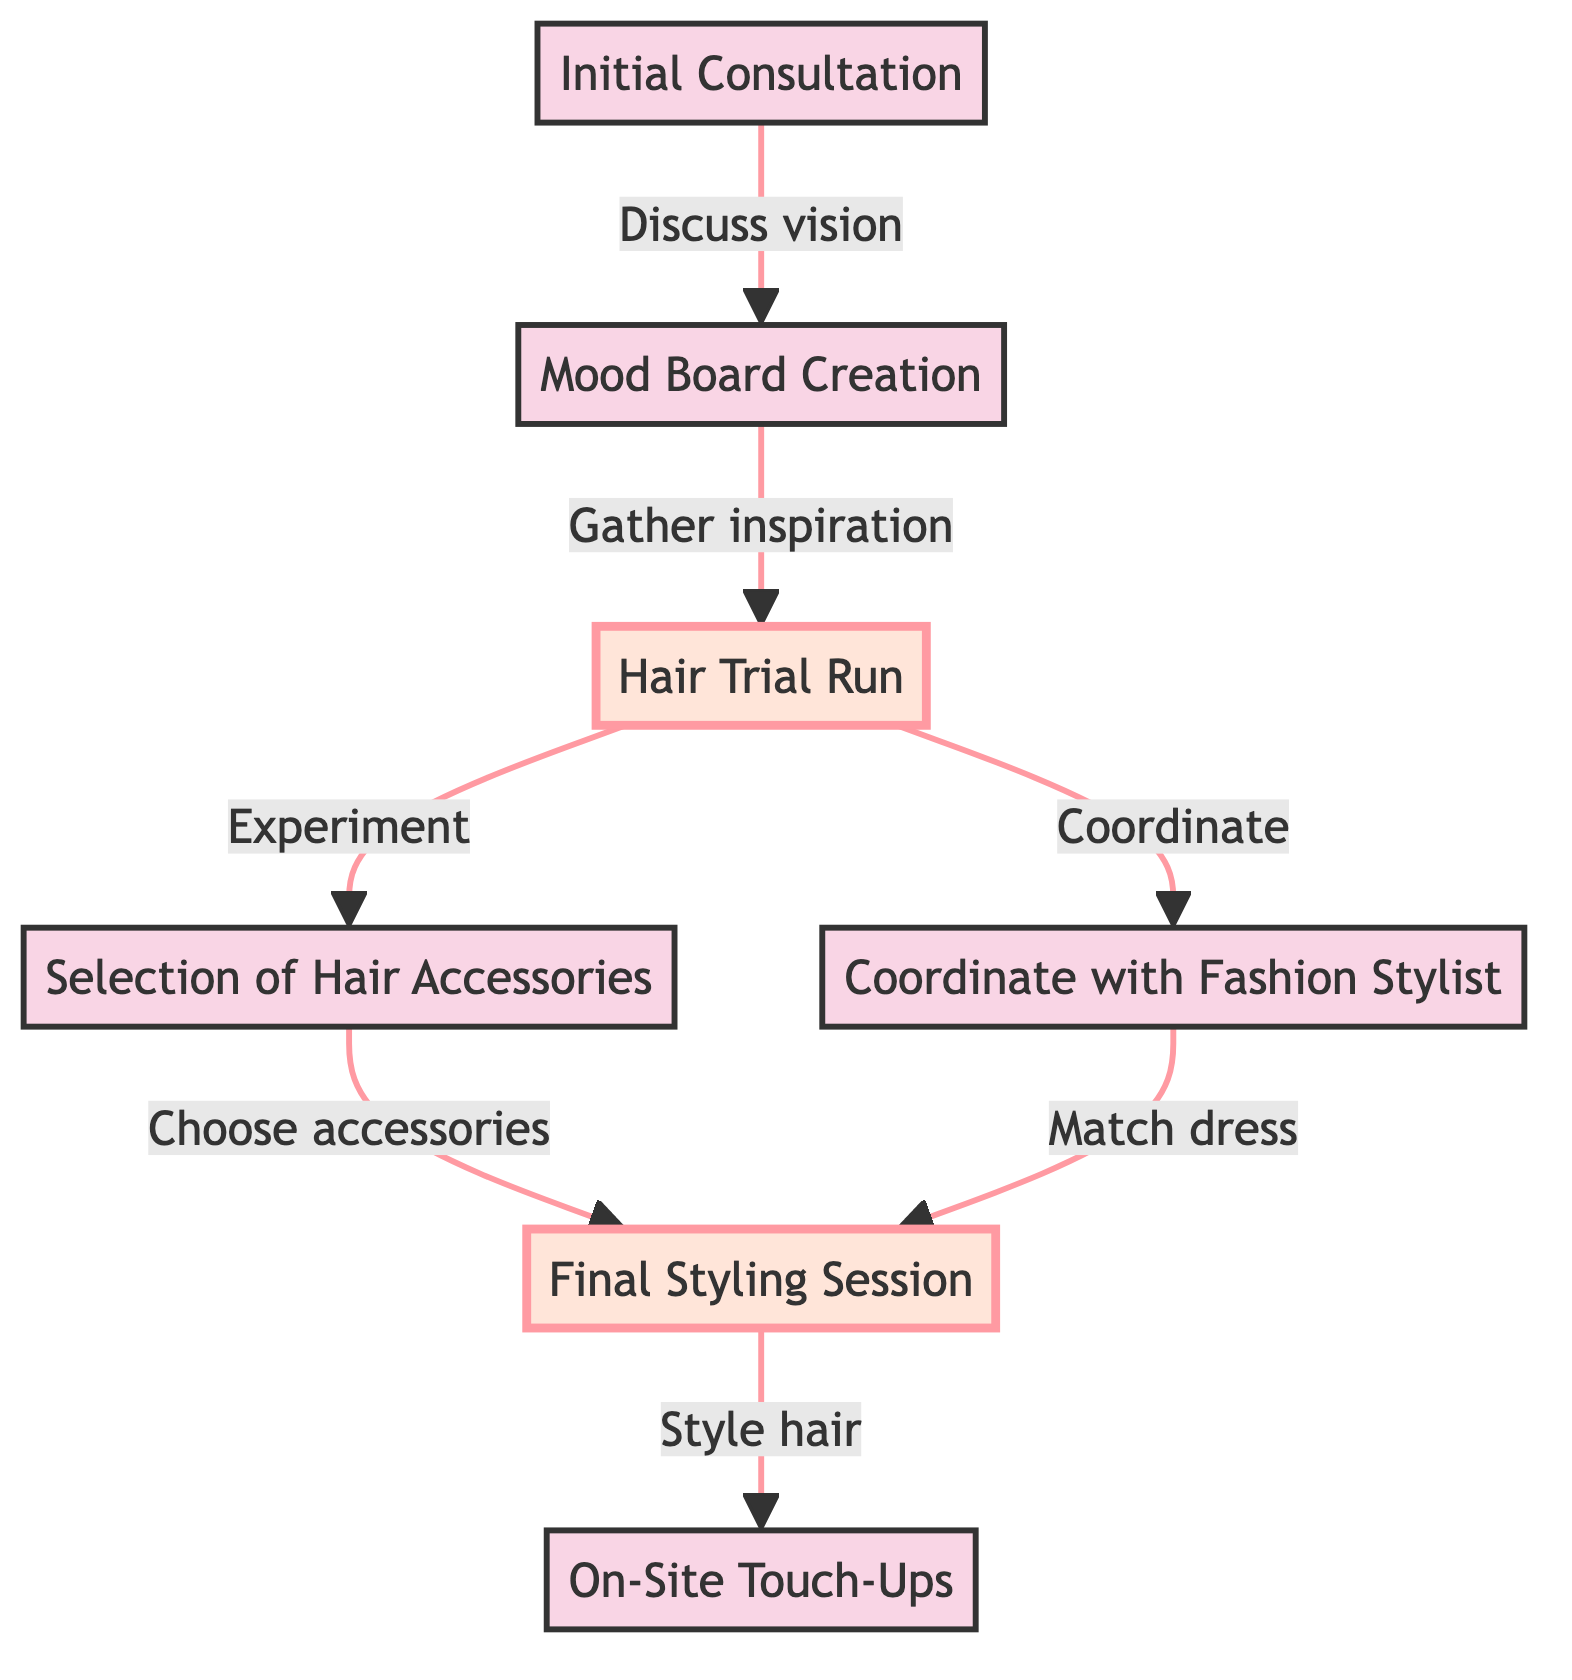What is the first step in the event preparation process? The first step listed in the diagram is "Initial Consultation." It is the starting point of the flow where Kathleen's vision for the event is discussed.
Answer: Initial Consultation How many total steps are represented in the diagram? The diagram contains seven elements, representing individual steps in the event preparation process. Each step is numbered from 1 to 7.
Answer: 7 Which step comes immediately after the "Hair Trial Run"? According to the diagram, after the "Hair Trial Run," the next step is "Selection of Hair Accessories" as shown by the directed flow from node 3 to node 4.
Answer: Selection of Hair Accessories What two steps coordinate together in the process? The diagram shows that the "Hair Trial Run" coordinates with "Coordinate with Fashion Stylist," indicating that these two steps work together at this point.
Answer: Hair Trial Run and Coordinate with Fashion Stylist How many steps lead to the "Final Styling Session"? Two steps lead to the "Final Styling Session": "Selection of Hair Accessories" and "Coordinate with Fashion Stylist." Both have directed edges pointing to node 6.
Answer: 2 What is the output of the "Final Styling Session"? The output is "On-Site Touch-Ups," which is the next step following the "Final Styling Session," indicating that touch-ups occur after final hairstyling.
Answer: On-Site Touch-Ups Which step involves gathering inspiration images? The step that involves gathering inspiration images is the "Mood Board Creation," as indicated in the flow from "Initial Consultation."
Answer: Mood Board Creation What is the relationship between "Hair Trial Run" and "Final Styling Session"? The "Hair Trial Run" influences both the "Selection of Hair Accessories" and "Coordinate with Fashion Stylist," which subsequently lead to the "Final Styling Session," signifying a process of preparation leading to finalization.
Answer: Influential preparation What is highlighted in the diagram? The highlighted parts of the diagram are the "Hair Trial Run" and "Final Styling Session," which have been visually emphasized to signify their importance in the process.
Answer: Hair Trial Run and Final Styling Session 